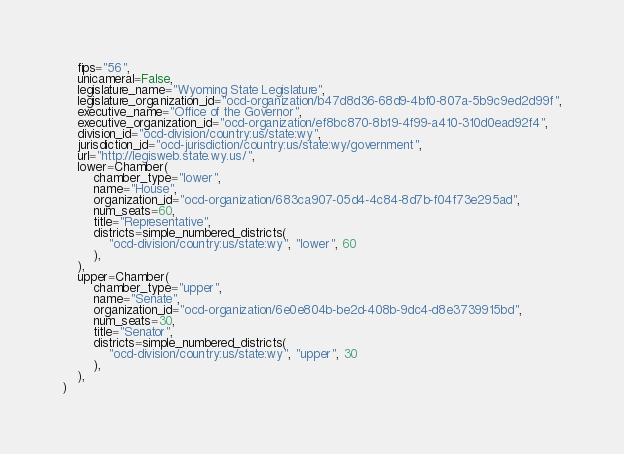<code> <loc_0><loc_0><loc_500><loc_500><_Python_>    fips="56",
    unicameral=False,
    legislature_name="Wyoming State Legislature",
    legislature_organization_id="ocd-organization/b47d8d36-68d9-4bf0-807a-5b9c9ed2d99f",
    executive_name="Office of the Governor",
    executive_organization_id="ocd-organization/ef8bc870-8b19-4f99-a410-310d0ead92f4",
    division_id="ocd-division/country:us/state:wy",
    jurisdiction_id="ocd-jurisdiction/country:us/state:wy/government",
    url="http://legisweb.state.wy.us/",
    lower=Chamber(
        chamber_type="lower",
        name="House",
        organization_id="ocd-organization/683ca907-05d4-4c84-8d7b-f04f73e295ad",
        num_seats=60,
        title="Representative",
        districts=simple_numbered_districts(
            "ocd-division/country:us/state:wy", "lower", 60
        ),
    ),
    upper=Chamber(
        chamber_type="upper",
        name="Senate",
        organization_id="ocd-organization/6e0e804b-be2d-408b-9dc4-d8e3739915bd",
        num_seats=30,
        title="Senator",
        districts=simple_numbered_districts(
            "ocd-division/country:us/state:wy", "upper", 30
        ),
    ),
)
</code> 